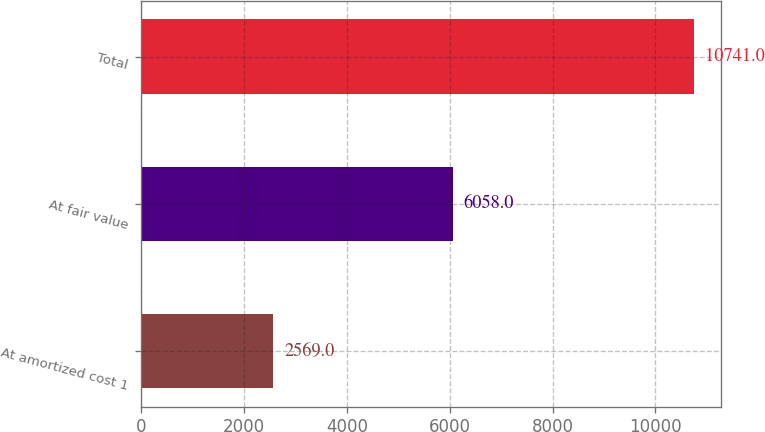Convert chart. <chart><loc_0><loc_0><loc_500><loc_500><bar_chart><fcel>At amortized cost 1<fcel>At fair value<fcel>Total<nl><fcel>2569<fcel>6058<fcel>10741<nl></chart> 